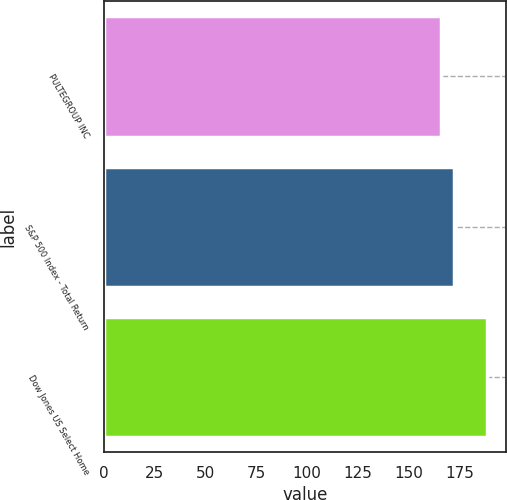Convert chart. <chart><loc_0><loc_0><loc_500><loc_500><bar_chart><fcel>PULTEGROUP INC<fcel>S&P 500 Index - Total Return<fcel>Dow Jones US Select Home<nl><fcel>166.15<fcel>172.37<fcel>188.49<nl></chart> 